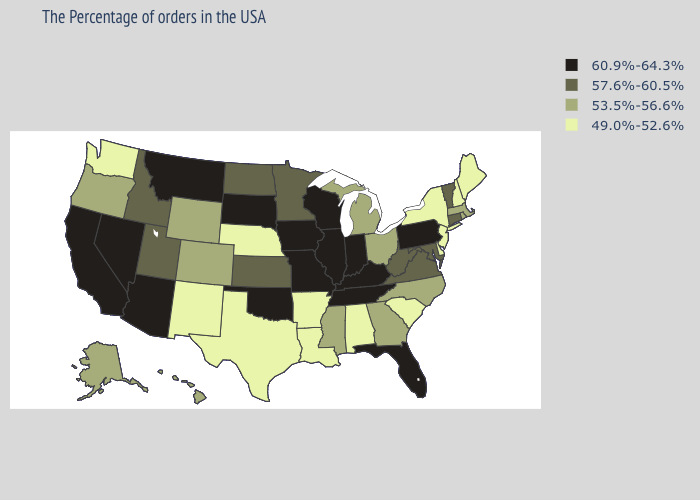Name the states that have a value in the range 49.0%-52.6%?
Keep it brief. Maine, New Hampshire, New York, New Jersey, Delaware, South Carolina, Alabama, Louisiana, Arkansas, Nebraska, Texas, New Mexico, Washington. Does Colorado have the same value as Vermont?
Keep it brief. No. Which states have the highest value in the USA?
Quick response, please. Pennsylvania, Florida, Kentucky, Indiana, Tennessee, Wisconsin, Illinois, Missouri, Iowa, Oklahoma, South Dakota, Montana, Arizona, Nevada, California. Does Pennsylvania have a higher value than Indiana?
Concise answer only. No. Name the states that have a value in the range 53.5%-56.6%?
Concise answer only. Massachusetts, Rhode Island, North Carolina, Ohio, Georgia, Michigan, Mississippi, Wyoming, Colorado, Oregon, Alaska, Hawaii. Name the states that have a value in the range 49.0%-52.6%?
Answer briefly. Maine, New Hampshire, New York, New Jersey, Delaware, South Carolina, Alabama, Louisiana, Arkansas, Nebraska, Texas, New Mexico, Washington. Name the states that have a value in the range 60.9%-64.3%?
Be succinct. Pennsylvania, Florida, Kentucky, Indiana, Tennessee, Wisconsin, Illinois, Missouri, Iowa, Oklahoma, South Dakota, Montana, Arizona, Nevada, California. Does Illinois have the lowest value in the MidWest?
Give a very brief answer. No. Is the legend a continuous bar?
Give a very brief answer. No. Does California have the lowest value in the USA?
Be succinct. No. Name the states that have a value in the range 53.5%-56.6%?
Give a very brief answer. Massachusetts, Rhode Island, North Carolina, Ohio, Georgia, Michigan, Mississippi, Wyoming, Colorado, Oregon, Alaska, Hawaii. What is the value of Delaware?
Keep it brief. 49.0%-52.6%. Name the states that have a value in the range 60.9%-64.3%?
Concise answer only. Pennsylvania, Florida, Kentucky, Indiana, Tennessee, Wisconsin, Illinois, Missouri, Iowa, Oklahoma, South Dakota, Montana, Arizona, Nevada, California. Does Tennessee have a lower value than New Jersey?
Give a very brief answer. No. 